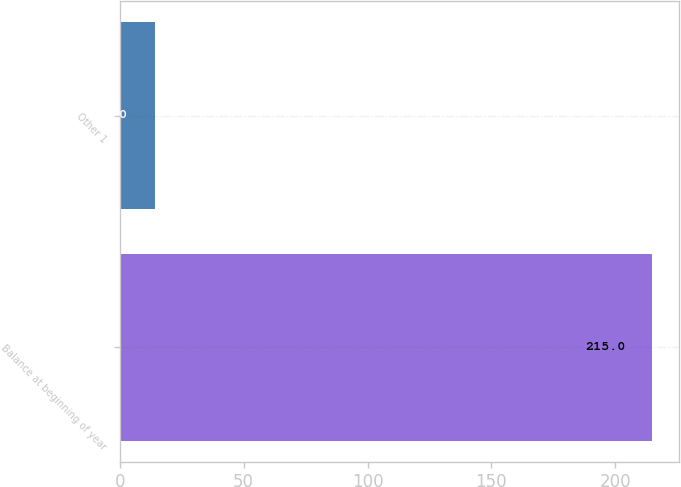<chart> <loc_0><loc_0><loc_500><loc_500><bar_chart><fcel>Balance at beginning of year<fcel>Other 1<nl><fcel>215<fcel>14<nl></chart> 